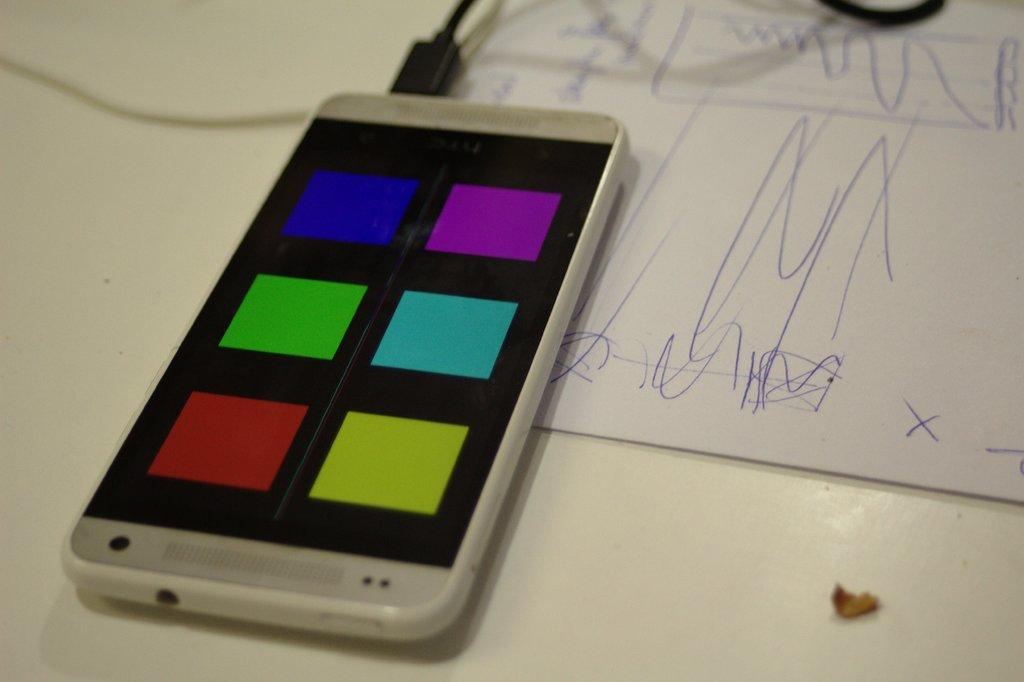What is the color of the table in the image? The table in the image is white. What electronic device is on the table? There is a mobile phone on the table. What is the mobile phone connected to? The mobile phone is connected to a black color charger. What type of paper is present in the image? There is a white color paper in the image. What type of structure is being built with the screws in the image? There are no screws or structures being built in the image; it only features a table, a mobile phone, a charger, and a white paper. 